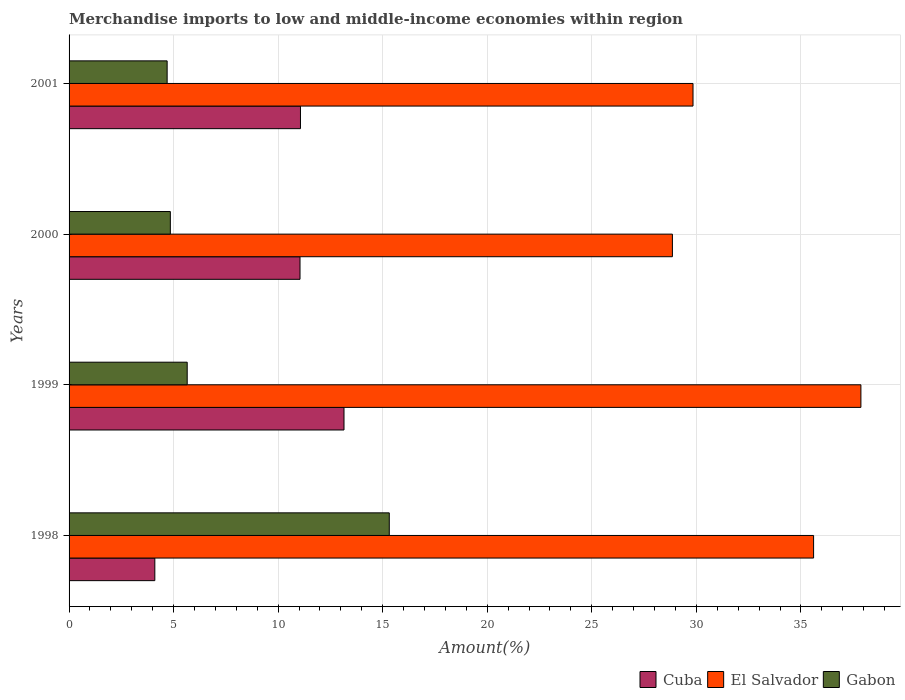How many groups of bars are there?
Offer a terse response. 4. Are the number of bars on each tick of the Y-axis equal?
Give a very brief answer. Yes. How many bars are there on the 2nd tick from the bottom?
Your answer should be very brief. 3. What is the label of the 3rd group of bars from the top?
Make the answer very short. 1999. What is the percentage of amount earned from merchandise imports in Gabon in 2001?
Your answer should be very brief. 4.69. Across all years, what is the maximum percentage of amount earned from merchandise imports in Gabon?
Offer a very short reply. 15.31. Across all years, what is the minimum percentage of amount earned from merchandise imports in Cuba?
Your answer should be very brief. 4.1. In which year was the percentage of amount earned from merchandise imports in Gabon minimum?
Your response must be concise. 2001. What is the total percentage of amount earned from merchandise imports in Cuba in the graph?
Give a very brief answer. 39.36. What is the difference between the percentage of amount earned from merchandise imports in Cuba in 1998 and that in 2001?
Your response must be concise. -6.97. What is the difference between the percentage of amount earned from merchandise imports in El Salvador in 2000 and the percentage of amount earned from merchandise imports in Gabon in 2001?
Your answer should be very brief. 24.16. What is the average percentage of amount earned from merchandise imports in El Salvador per year?
Offer a terse response. 33.04. In the year 2001, what is the difference between the percentage of amount earned from merchandise imports in Cuba and percentage of amount earned from merchandise imports in El Salvador?
Make the answer very short. -18.77. In how many years, is the percentage of amount earned from merchandise imports in El Salvador greater than 4 %?
Keep it short and to the point. 4. What is the ratio of the percentage of amount earned from merchandise imports in Gabon in 2000 to that in 2001?
Keep it short and to the point. 1.03. Is the difference between the percentage of amount earned from merchandise imports in Cuba in 1998 and 2001 greater than the difference between the percentage of amount earned from merchandise imports in El Salvador in 1998 and 2001?
Make the answer very short. No. What is the difference between the highest and the second highest percentage of amount earned from merchandise imports in Gabon?
Keep it short and to the point. 9.66. What is the difference between the highest and the lowest percentage of amount earned from merchandise imports in Cuba?
Your response must be concise. 9.05. What does the 3rd bar from the top in 2001 represents?
Keep it short and to the point. Cuba. What does the 1st bar from the bottom in 1998 represents?
Keep it short and to the point. Cuba. Is it the case that in every year, the sum of the percentage of amount earned from merchandise imports in El Salvador and percentage of amount earned from merchandise imports in Cuba is greater than the percentage of amount earned from merchandise imports in Gabon?
Make the answer very short. Yes. How many years are there in the graph?
Your answer should be compact. 4. Are the values on the major ticks of X-axis written in scientific E-notation?
Your answer should be compact. No. Does the graph contain any zero values?
Offer a very short reply. No. How are the legend labels stacked?
Ensure brevity in your answer.  Horizontal. What is the title of the graph?
Provide a short and direct response. Merchandise imports to low and middle-income economies within region. What is the label or title of the X-axis?
Your answer should be compact. Amount(%). What is the label or title of the Y-axis?
Provide a short and direct response. Years. What is the Amount(%) in Cuba in 1998?
Offer a terse response. 4.1. What is the Amount(%) of El Salvador in 1998?
Offer a very short reply. 35.61. What is the Amount(%) in Gabon in 1998?
Your response must be concise. 15.31. What is the Amount(%) of Cuba in 1999?
Offer a very short reply. 13.15. What is the Amount(%) in El Salvador in 1999?
Give a very brief answer. 37.87. What is the Amount(%) in Gabon in 1999?
Offer a terse response. 5.65. What is the Amount(%) in Cuba in 2000?
Offer a very short reply. 11.05. What is the Amount(%) in El Salvador in 2000?
Offer a very short reply. 28.85. What is the Amount(%) in Gabon in 2000?
Provide a short and direct response. 4.84. What is the Amount(%) in Cuba in 2001?
Make the answer very short. 11.07. What is the Amount(%) of El Salvador in 2001?
Your answer should be very brief. 29.84. What is the Amount(%) in Gabon in 2001?
Offer a terse response. 4.69. Across all years, what is the maximum Amount(%) of Cuba?
Your answer should be compact. 13.15. Across all years, what is the maximum Amount(%) of El Salvador?
Give a very brief answer. 37.87. Across all years, what is the maximum Amount(%) of Gabon?
Your answer should be compact. 15.31. Across all years, what is the minimum Amount(%) of Cuba?
Your answer should be compact. 4.1. Across all years, what is the minimum Amount(%) of El Salvador?
Give a very brief answer. 28.85. Across all years, what is the minimum Amount(%) in Gabon?
Your answer should be very brief. 4.69. What is the total Amount(%) in Cuba in the graph?
Make the answer very short. 39.36. What is the total Amount(%) of El Salvador in the graph?
Keep it short and to the point. 132.17. What is the total Amount(%) of Gabon in the graph?
Offer a very short reply. 30.5. What is the difference between the Amount(%) in Cuba in 1998 and that in 1999?
Ensure brevity in your answer.  -9.05. What is the difference between the Amount(%) of El Salvador in 1998 and that in 1999?
Provide a short and direct response. -2.26. What is the difference between the Amount(%) in Gabon in 1998 and that in 1999?
Your response must be concise. 9.66. What is the difference between the Amount(%) of Cuba in 1998 and that in 2000?
Keep it short and to the point. -6.94. What is the difference between the Amount(%) in El Salvador in 1998 and that in 2000?
Your response must be concise. 6.75. What is the difference between the Amount(%) of Gabon in 1998 and that in 2000?
Your response must be concise. 10.47. What is the difference between the Amount(%) in Cuba in 1998 and that in 2001?
Provide a succinct answer. -6.97. What is the difference between the Amount(%) in El Salvador in 1998 and that in 2001?
Provide a succinct answer. 5.77. What is the difference between the Amount(%) in Gabon in 1998 and that in 2001?
Your answer should be very brief. 10.62. What is the difference between the Amount(%) of Cuba in 1999 and that in 2000?
Your answer should be compact. 2.1. What is the difference between the Amount(%) in El Salvador in 1999 and that in 2000?
Your answer should be compact. 9.01. What is the difference between the Amount(%) of Gabon in 1999 and that in 2000?
Your answer should be compact. 0.81. What is the difference between the Amount(%) in Cuba in 1999 and that in 2001?
Your response must be concise. 2.08. What is the difference between the Amount(%) in El Salvador in 1999 and that in 2001?
Make the answer very short. 8.03. What is the difference between the Amount(%) of Gabon in 1999 and that in 2001?
Ensure brevity in your answer.  0.96. What is the difference between the Amount(%) of Cuba in 2000 and that in 2001?
Provide a succinct answer. -0.02. What is the difference between the Amount(%) in El Salvador in 2000 and that in 2001?
Offer a terse response. -0.99. What is the difference between the Amount(%) in Gabon in 2000 and that in 2001?
Provide a succinct answer. 0.15. What is the difference between the Amount(%) of Cuba in 1998 and the Amount(%) of El Salvador in 1999?
Offer a terse response. -33.77. What is the difference between the Amount(%) of Cuba in 1998 and the Amount(%) of Gabon in 1999?
Your answer should be very brief. -1.55. What is the difference between the Amount(%) of El Salvador in 1998 and the Amount(%) of Gabon in 1999?
Ensure brevity in your answer.  29.96. What is the difference between the Amount(%) in Cuba in 1998 and the Amount(%) in El Salvador in 2000?
Your answer should be very brief. -24.75. What is the difference between the Amount(%) of Cuba in 1998 and the Amount(%) of Gabon in 2000?
Offer a very short reply. -0.74. What is the difference between the Amount(%) in El Salvador in 1998 and the Amount(%) in Gabon in 2000?
Your response must be concise. 30.76. What is the difference between the Amount(%) in Cuba in 1998 and the Amount(%) in El Salvador in 2001?
Offer a terse response. -25.74. What is the difference between the Amount(%) of Cuba in 1998 and the Amount(%) of Gabon in 2001?
Offer a very short reply. -0.59. What is the difference between the Amount(%) of El Salvador in 1998 and the Amount(%) of Gabon in 2001?
Offer a very short reply. 30.92. What is the difference between the Amount(%) of Cuba in 1999 and the Amount(%) of El Salvador in 2000?
Your answer should be compact. -15.71. What is the difference between the Amount(%) in Cuba in 1999 and the Amount(%) in Gabon in 2000?
Make the answer very short. 8.31. What is the difference between the Amount(%) in El Salvador in 1999 and the Amount(%) in Gabon in 2000?
Offer a very short reply. 33.03. What is the difference between the Amount(%) in Cuba in 1999 and the Amount(%) in El Salvador in 2001?
Keep it short and to the point. -16.69. What is the difference between the Amount(%) of Cuba in 1999 and the Amount(%) of Gabon in 2001?
Keep it short and to the point. 8.46. What is the difference between the Amount(%) of El Salvador in 1999 and the Amount(%) of Gabon in 2001?
Ensure brevity in your answer.  33.18. What is the difference between the Amount(%) of Cuba in 2000 and the Amount(%) of El Salvador in 2001?
Give a very brief answer. -18.79. What is the difference between the Amount(%) of Cuba in 2000 and the Amount(%) of Gabon in 2001?
Offer a terse response. 6.35. What is the difference between the Amount(%) in El Salvador in 2000 and the Amount(%) in Gabon in 2001?
Your answer should be very brief. 24.16. What is the average Amount(%) in Cuba per year?
Offer a terse response. 9.84. What is the average Amount(%) in El Salvador per year?
Offer a terse response. 33.04. What is the average Amount(%) of Gabon per year?
Offer a very short reply. 7.62. In the year 1998, what is the difference between the Amount(%) in Cuba and Amount(%) in El Salvador?
Ensure brevity in your answer.  -31.51. In the year 1998, what is the difference between the Amount(%) of Cuba and Amount(%) of Gabon?
Keep it short and to the point. -11.21. In the year 1998, what is the difference between the Amount(%) of El Salvador and Amount(%) of Gabon?
Offer a terse response. 20.29. In the year 1999, what is the difference between the Amount(%) in Cuba and Amount(%) in El Salvador?
Offer a very short reply. -24.72. In the year 1999, what is the difference between the Amount(%) of Cuba and Amount(%) of Gabon?
Ensure brevity in your answer.  7.5. In the year 1999, what is the difference between the Amount(%) of El Salvador and Amount(%) of Gabon?
Provide a short and direct response. 32.22. In the year 2000, what is the difference between the Amount(%) in Cuba and Amount(%) in El Salvador?
Your response must be concise. -17.81. In the year 2000, what is the difference between the Amount(%) of Cuba and Amount(%) of Gabon?
Your answer should be compact. 6.2. In the year 2000, what is the difference between the Amount(%) of El Salvador and Amount(%) of Gabon?
Keep it short and to the point. 24.01. In the year 2001, what is the difference between the Amount(%) of Cuba and Amount(%) of El Salvador?
Your answer should be compact. -18.77. In the year 2001, what is the difference between the Amount(%) of Cuba and Amount(%) of Gabon?
Provide a succinct answer. 6.38. In the year 2001, what is the difference between the Amount(%) of El Salvador and Amount(%) of Gabon?
Ensure brevity in your answer.  25.15. What is the ratio of the Amount(%) in Cuba in 1998 to that in 1999?
Ensure brevity in your answer.  0.31. What is the ratio of the Amount(%) of El Salvador in 1998 to that in 1999?
Offer a terse response. 0.94. What is the ratio of the Amount(%) of Gabon in 1998 to that in 1999?
Your answer should be very brief. 2.71. What is the ratio of the Amount(%) in Cuba in 1998 to that in 2000?
Your response must be concise. 0.37. What is the ratio of the Amount(%) in El Salvador in 1998 to that in 2000?
Your answer should be compact. 1.23. What is the ratio of the Amount(%) in Gabon in 1998 to that in 2000?
Give a very brief answer. 3.16. What is the ratio of the Amount(%) of Cuba in 1998 to that in 2001?
Provide a short and direct response. 0.37. What is the ratio of the Amount(%) in El Salvador in 1998 to that in 2001?
Ensure brevity in your answer.  1.19. What is the ratio of the Amount(%) of Gabon in 1998 to that in 2001?
Provide a short and direct response. 3.27. What is the ratio of the Amount(%) in Cuba in 1999 to that in 2000?
Your response must be concise. 1.19. What is the ratio of the Amount(%) in El Salvador in 1999 to that in 2000?
Provide a short and direct response. 1.31. What is the ratio of the Amount(%) in Gabon in 1999 to that in 2000?
Offer a very short reply. 1.17. What is the ratio of the Amount(%) of Cuba in 1999 to that in 2001?
Your answer should be compact. 1.19. What is the ratio of the Amount(%) in El Salvador in 1999 to that in 2001?
Keep it short and to the point. 1.27. What is the ratio of the Amount(%) of Gabon in 1999 to that in 2001?
Your response must be concise. 1.2. What is the ratio of the Amount(%) in Gabon in 2000 to that in 2001?
Give a very brief answer. 1.03. What is the difference between the highest and the second highest Amount(%) of Cuba?
Give a very brief answer. 2.08. What is the difference between the highest and the second highest Amount(%) of El Salvador?
Keep it short and to the point. 2.26. What is the difference between the highest and the second highest Amount(%) in Gabon?
Ensure brevity in your answer.  9.66. What is the difference between the highest and the lowest Amount(%) in Cuba?
Your answer should be very brief. 9.05. What is the difference between the highest and the lowest Amount(%) in El Salvador?
Your answer should be compact. 9.01. What is the difference between the highest and the lowest Amount(%) of Gabon?
Provide a short and direct response. 10.62. 